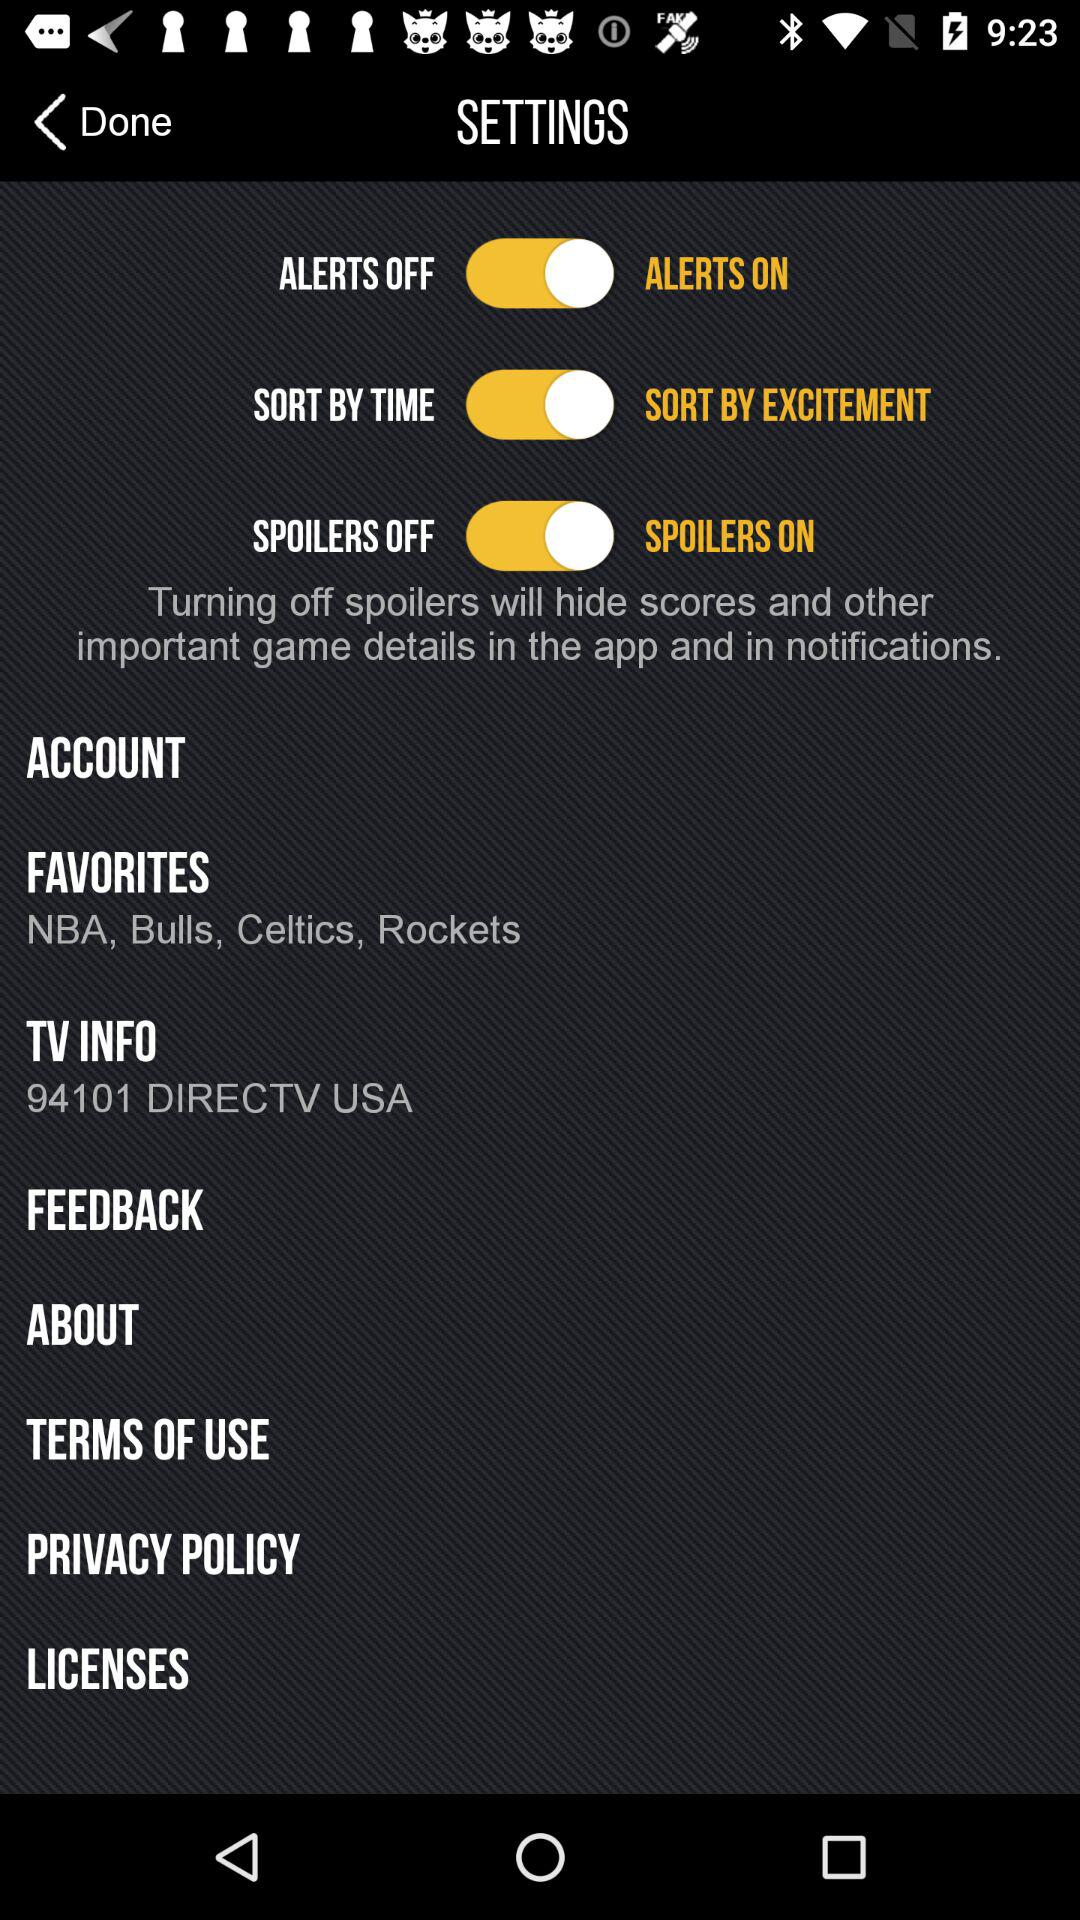What are the favorites? The favorites are "NBA", "Bulls", "Celtics" and "Rockets". 